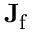Convert formula to latex. <formula><loc_0><loc_0><loc_500><loc_500>J _ { f }</formula> 